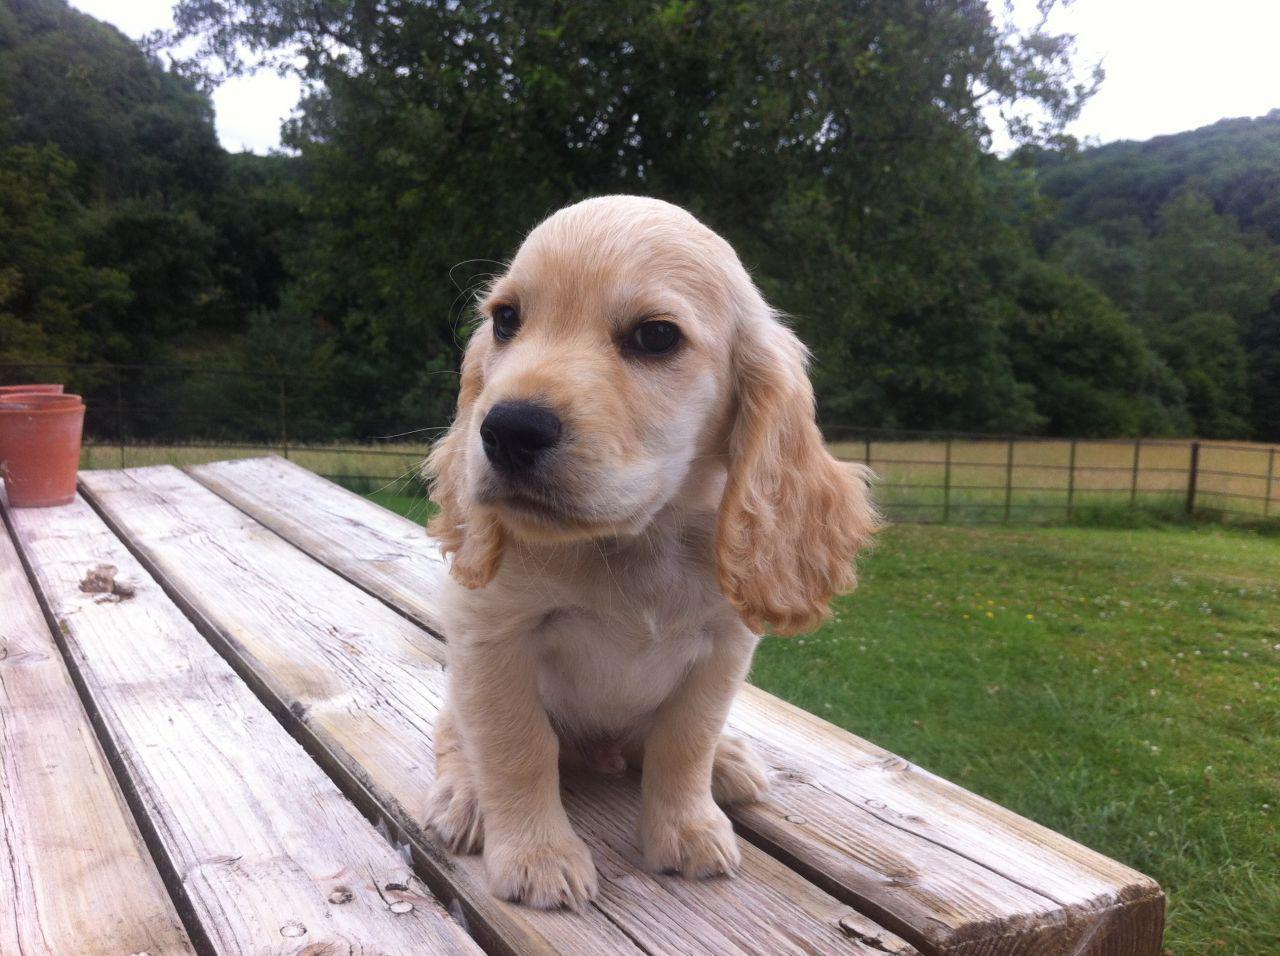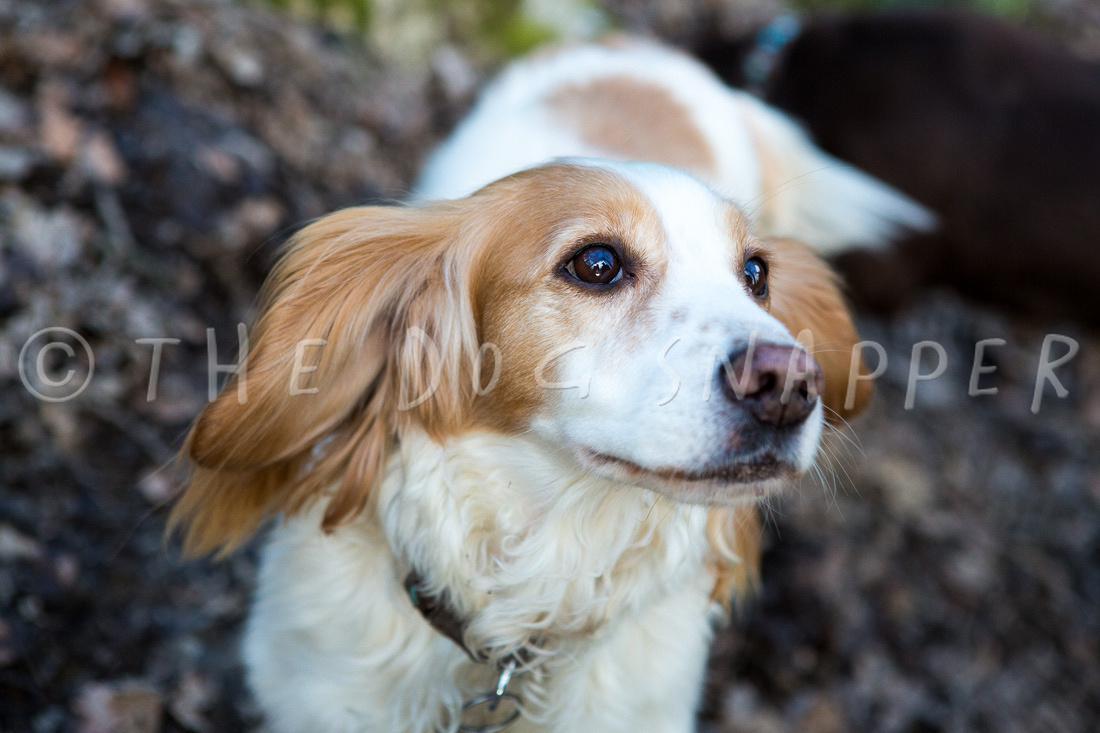The first image is the image on the left, the second image is the image on the right. Considering the images on both sides, is "One of the dogs is white with black spots." valid? Answer yes or no. No. 